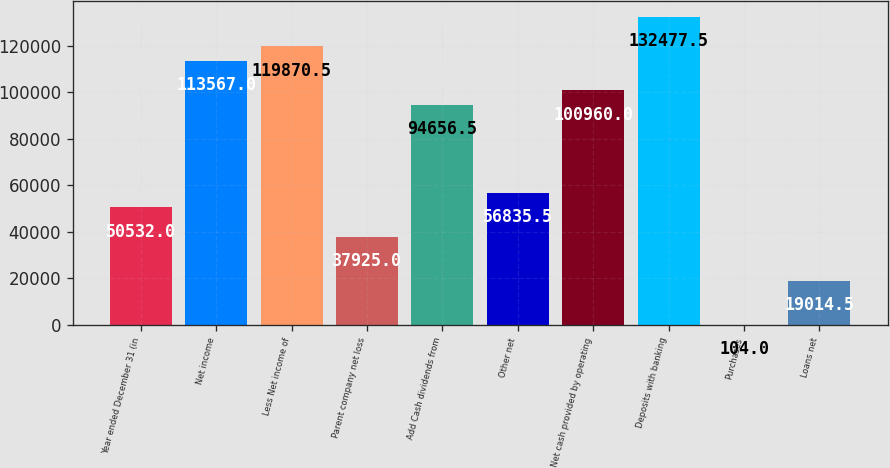<chart> <loc_0><loc_0><loc_500><loc_500><bar_chart><fcel>Year ended December 31 (in<fcel>Net income<fcel>Less Net income of<fcel>Parent company net loss<fcel>Add Cash dividends from<fcel>Other net<fcel>Net cash provided by operating<fcel>Deposits with banking<fcel>Purchases<fcel>Loans net<nl><fcel>50532<fcel>113567<fcel>119870<fcel>37925<fcel>94656.5<fcel>56835.5<fcel>100960<fcel>132478<fcel>104<fcel>19014.5<nl></chart> 